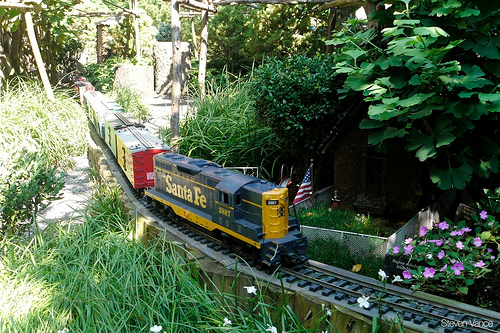What might the future of this scene look like? In the future, this enchanting garden might become even more intricate and captivating. The train set could be expanded to include multiple tracks interwoven with more complex routes, tiny stations, and detailed miniatures of bustling towns. Technological enhancements might see the incorporation of motion sensors, triggering the train to start moving as soon as an observer approaches. Seasonal decorations could add a dynamic element, with blooming flowers in spring, lush leaves in summer, vibrant foliage in autumn, and twinkling lights for a winter wonderland. Additionally, an augmented reality app might allow visitors to see stories and mythical creatures come to life, blending real-world and digital experiences into a multi-sensory journey. What creatures or characters could you imagine living in this miniature world? In this miniature world, one might imagine a variety of whimsical creatures and characters inhabiting the vibrant landscape. Tiny fairies with iridescent wings could flit among the flowers, while gnomes with pointy hats busily tend to the gardens. There could be miniature animals as well, such as industrious ants carrying food back to their hidden nests or small birds chirping from branches. In the small houses, one might find a family of elves crafting beautiful, delicate items from natural materials found in the garden. Perhaps even a wise, gentle dragon, small enough to coexist peacefully with its neighbors, could guard the train tracks and ensure the safety of all inhabitants. This world would be a harmonious blend of nature and fantasy, where every corner holds the promise of a new discovery. 